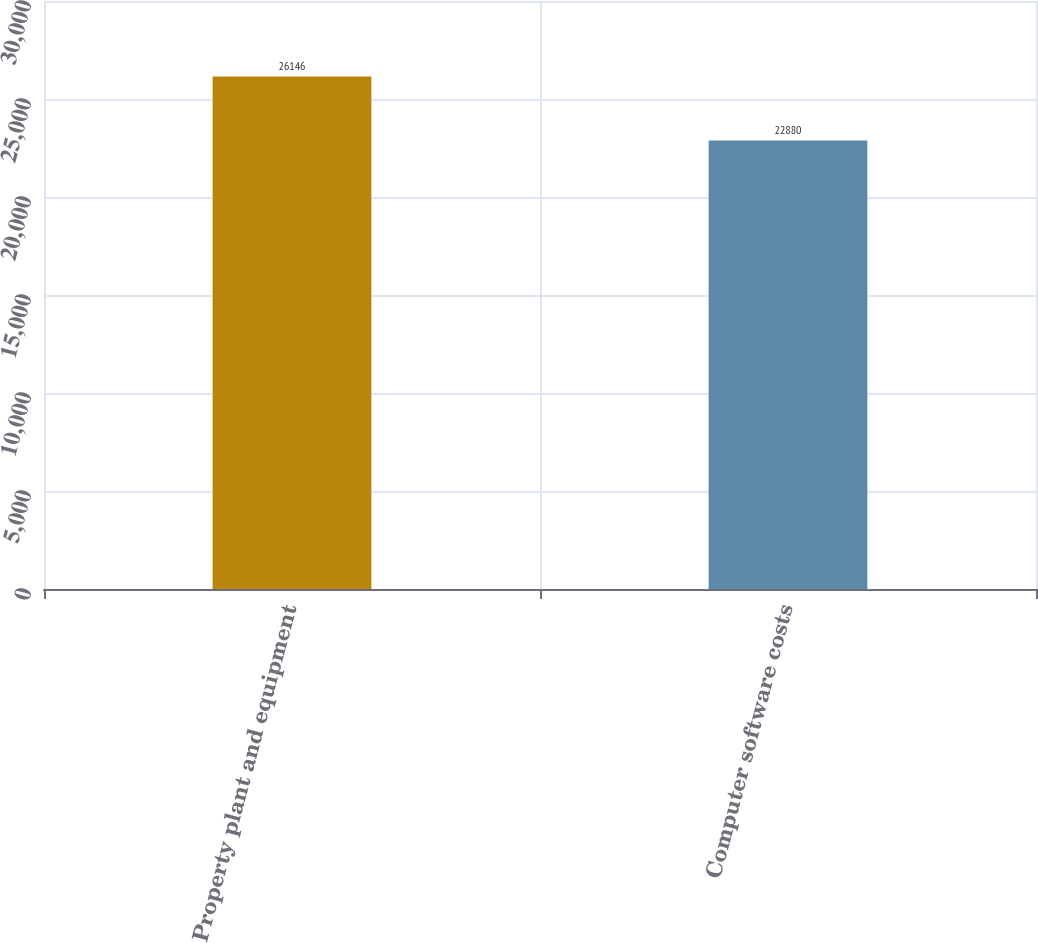Convert chart. <chart><loc_0><loc_0><loc_500><loc_500><bar_chart><fcel>Property plant and equipment<fcel>Computer software costs<nl><fcel>26146<fcel>22880<nl></chart> 